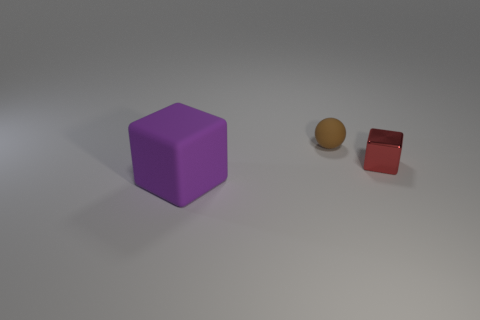What number of objects are either rubber things that are behind the large thing or small brown objects that are behind the tiny cube?
Make the answer very short. 1. What number of other objects are there of the same size as the sphere?
Ensure brevity in your answer.  1. There is a rubber object that is behind the matte thing to the left of the small brown rubber object; what shape is it?
Provide a short and direct response. Sphere. The shiny thing is what color?
Your answer should be very brief. Red. Are there any small metallic objects?
Keep it short and to the point. Yes. There is a tiny ball; are there any big purple things in front of it?
Give a very brief answer. Yes. There is another large thing that is the same shape as the metal object; what is it made of?
Your response must be concise. Rubber. Is there any other thing that has the same material as the tiny red object?
Offer a terse response. No. How many other objects are there of the same shape as the tiny brown thing?
Provide a succinct answer. 0. There is a block that is right of the object that is in front of the tiny block; how many tiny cubes are to the left of it?
Offer a very short reply. 0. 